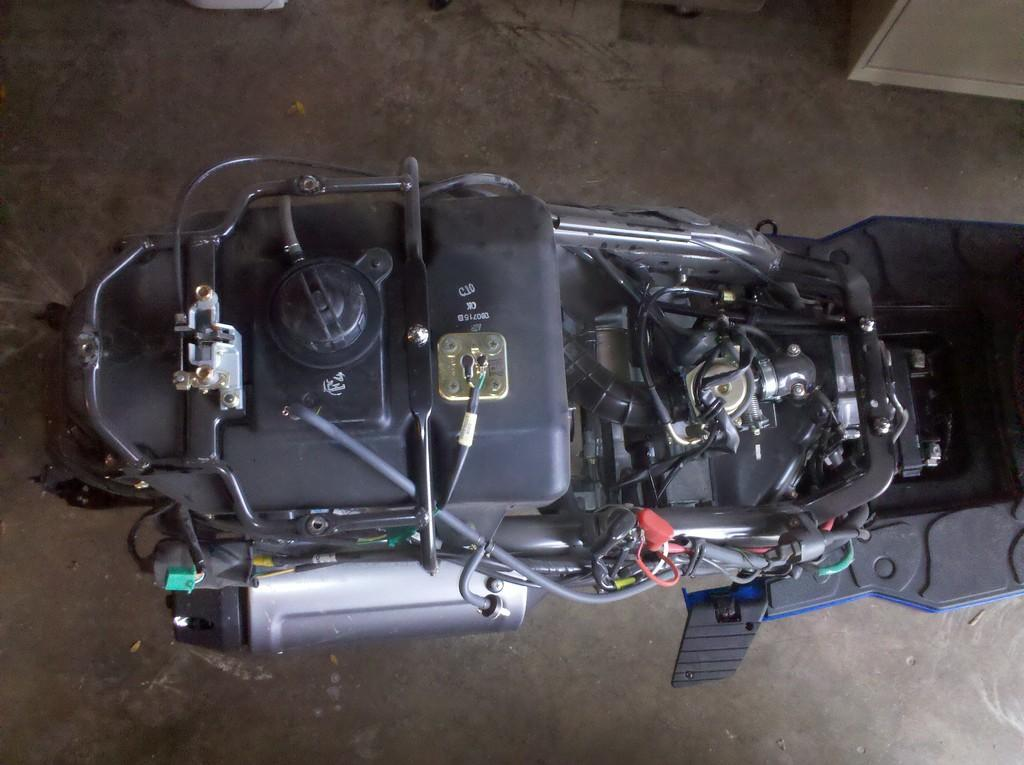What type of machinery is present in the image? There is an engine in the image. What type of vehicle does the engine belong to? The engine belongs to a bike. What type of cannon is present in the image? There is no cannon present in the image; it features an engine from a bike. What type of jewel can be seen adorning the engine in the image? There is no jewel present in the image; it features an engine from a bike. 